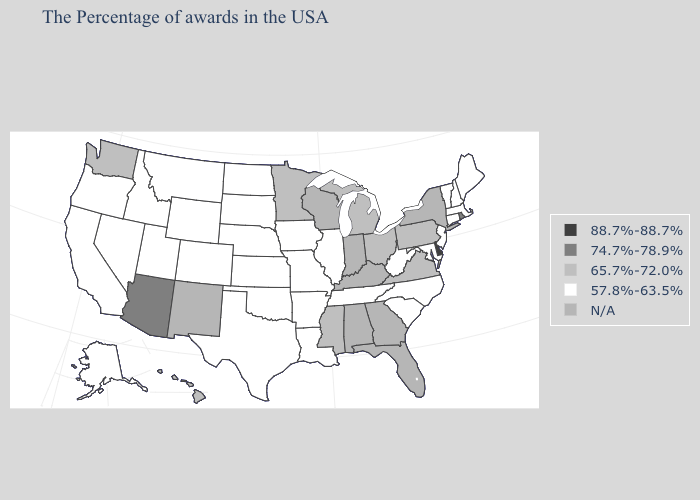Among the states that border Massachusetts , which have the lowest value?
Concise answer only. New Hampshire, Vermont, Connecticut. Does the first symbol in the legend represent the smallest category?
Quick response, please. No. Does Hawaii have the lowest value in the USA?
Write a very short answer. No. Name the states that have a value in the range 57.8%-63.5%?
Write a very short answer. Maine, Massachusetts, New Hampshire, Vermont, Connecticut, New Jersey, Maryland, North Carolina, South Carolina, West Virginia, Tennessee, Illinois, Louisiana, Missouri, Arkansas, Iowa, Kansas, Nebraska, Oklahoma, Texas, South Dakota, North Dakota, Wyoming, Colorado, Utah, Montana, Idaho, Nevada, California, Oregon, Alaska. Does the map have missing data?
Write a very short answer. Yes. What is the lowest value in states that border South Carolina?
Give a very brief answer. 57.8%-63.5%. Does Delaware have the highest value in the USA?
Short answer required. Yes. What is the value of Montana?
Be succinct. 57.8%-63.5%. Name the states that have a value in the range 88.7%-88.7%?
Answer briefly. Delaware. What is the value of Michigan?
Write a very short answer. 65.7%-72.0%. What is the value of Ohio?
Quick response, please. 65.7%-72.0%. Name the states that have a value in the range N/A?
Be succinct. New York, Florida, Georgia, Kentucky, Indiana, Alabama, Wisconsin, New Mexico. Name the states that have a value in the range 74.7%-78.9%?
Give a very brief answer. Rhode Island, Arizona. Name the states that have a value in the range 57.8%-63.5%?
Keep it brief. Maine, Massachusetts, New Hampshire, Vermont, Connecticut, New Jersey, Maryland, North Carolina, South Carolina, West Virginia, Tennessee, Illinois, Louisiana, Missouri, Arkansas, Iowa, Kansas, Nebraska, Oklahoma, Texas, South Dakota, North Dakota, Wyoming, Colorado, Utah, Montana, Idaho, Nevada, California, Oregon, Alaska. 